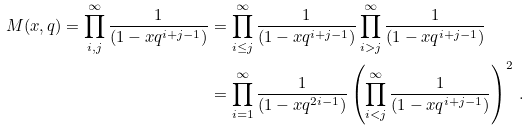Convert formula to latex. <formula><loc_0><loc_0><loc_500><loc_500>M ( x , q ) = \prod _ { i , j } ^ { \infty } \frac { 1 } { ( 1 - x q ^ { i + j - 1 } ) } & = \prod _ { i \leq j } ^ { \infty } \frac { 1 } { ( 1 - x q ^ { i + j - 1 } ) } \prod _ { i > j } ^ { \infty } \frac { 1 } { ( 1 - x q ^ { i + j - 1 } ) } \\ & = \prod _ { i = 1 } ^ { \infty } \frac { 1 } { ( 1 - x q ^ { 2 i - 1 } ) } \left ( \prod _ { i < j } ^ { \infty } \frac { 1 } { ( 1 - x q ^ { i + j - 1 } ) } \right ) ^ { 2 } \, .</formula> 